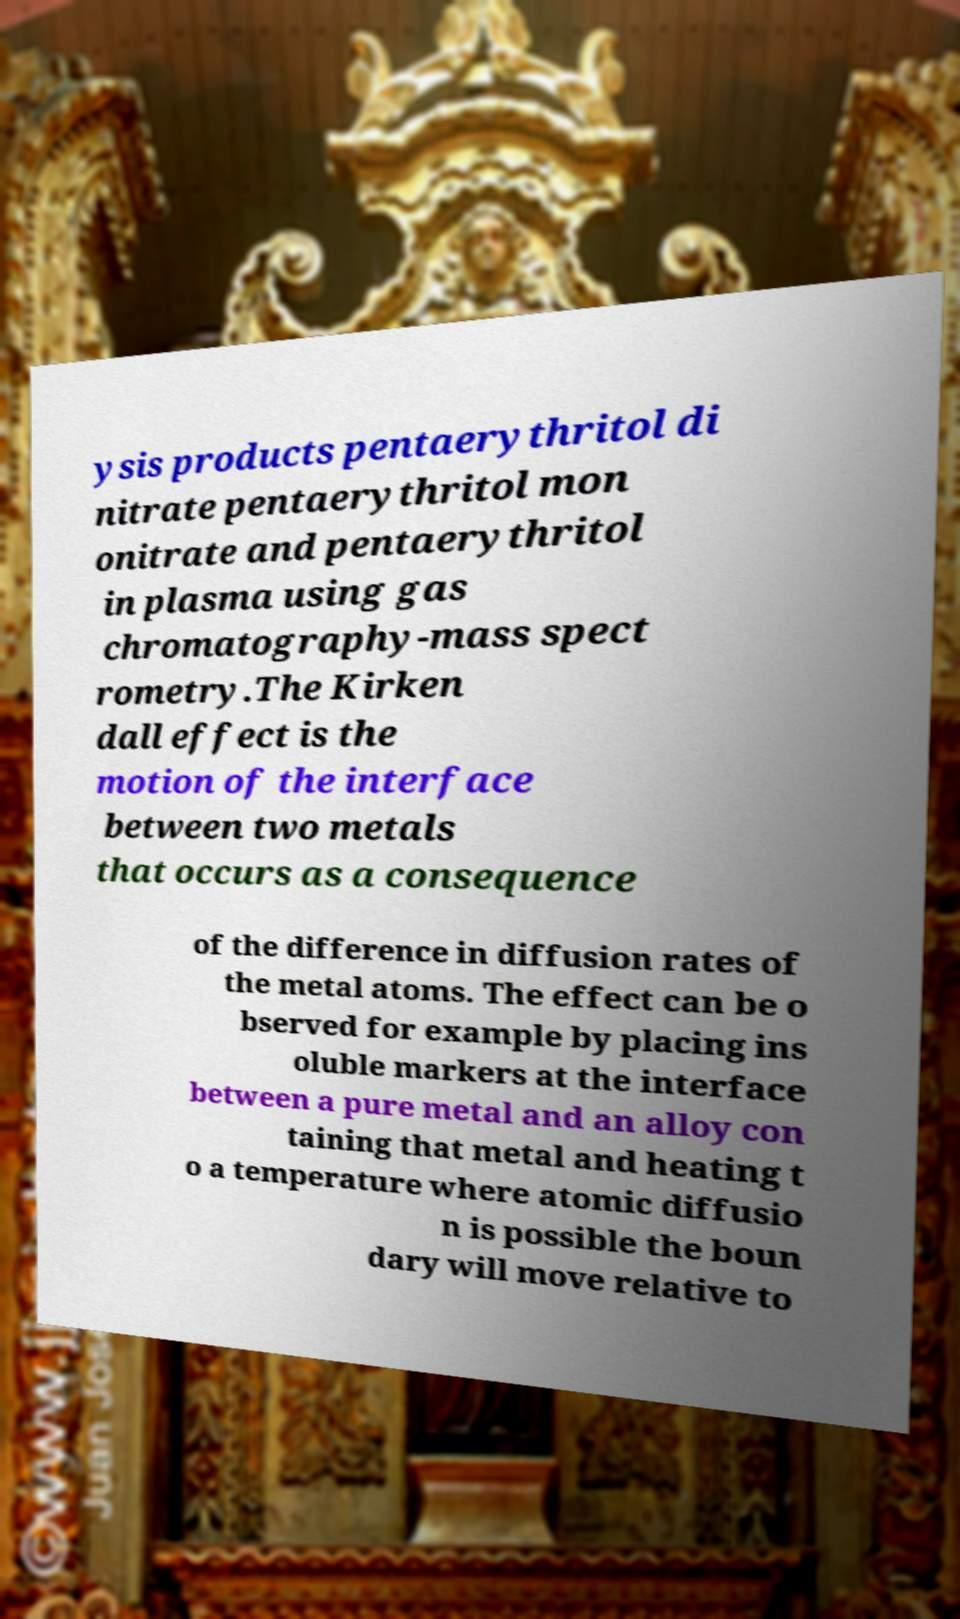What messages or text are displayed in this image? I need them in a readable, typed format. ysis products pentaerythritol di nitrate pentaerythritol mon onitrate and pentaerythritol in plasma using gas chromatography-mass spect rometry.The Kirken dall effect is the motion of the interface between two metals that occurs as a consequence of the difference in diffusion rates of the metal atoms. The effect can be o bserved for example by placing ins oluble markers at the interface between a pure metal and an alloy con taining that metal and heating t o a temperature where atomic diffusio n is possible the boun dary will move relative to 